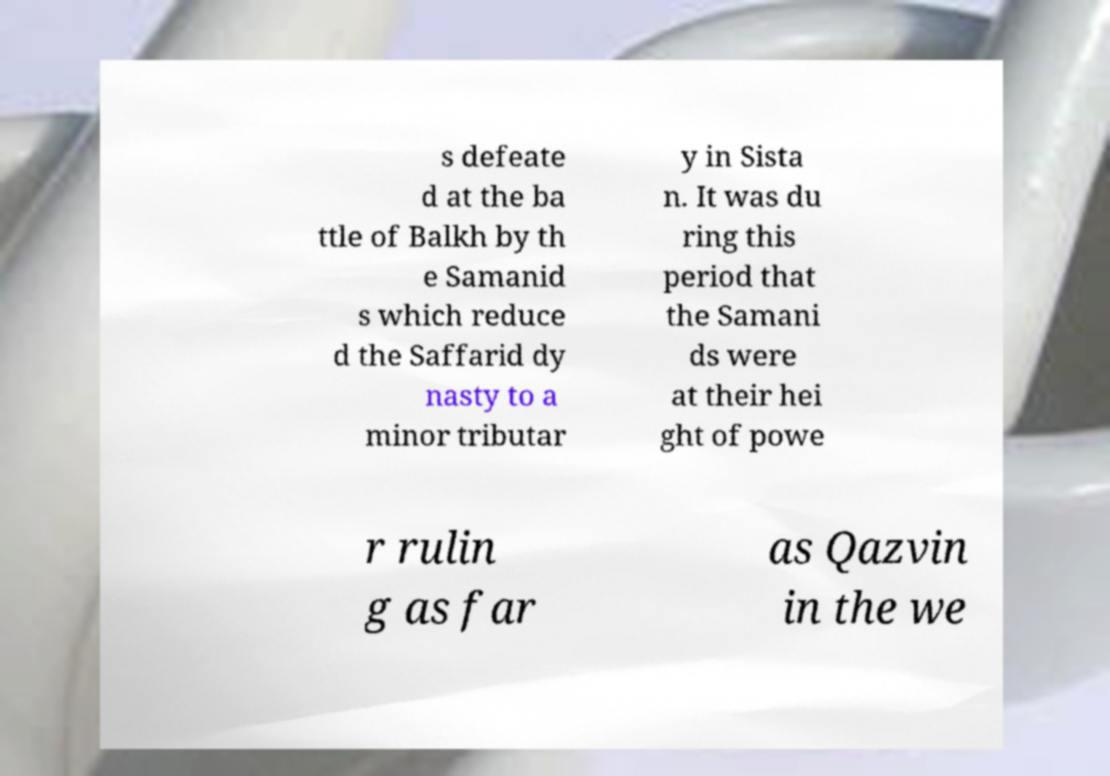For documentation purposes, I need the text within this image transcribed. Could you provide that? s defeate d at the ba ttle of Balkh by th e Samanid s which reduce d the Saffarid dy nasty to a minor tributar y in Sista n. It was du ring this period that the Samani ds were at their hei ght of powe r rulin g as far as Qazvin in the we 